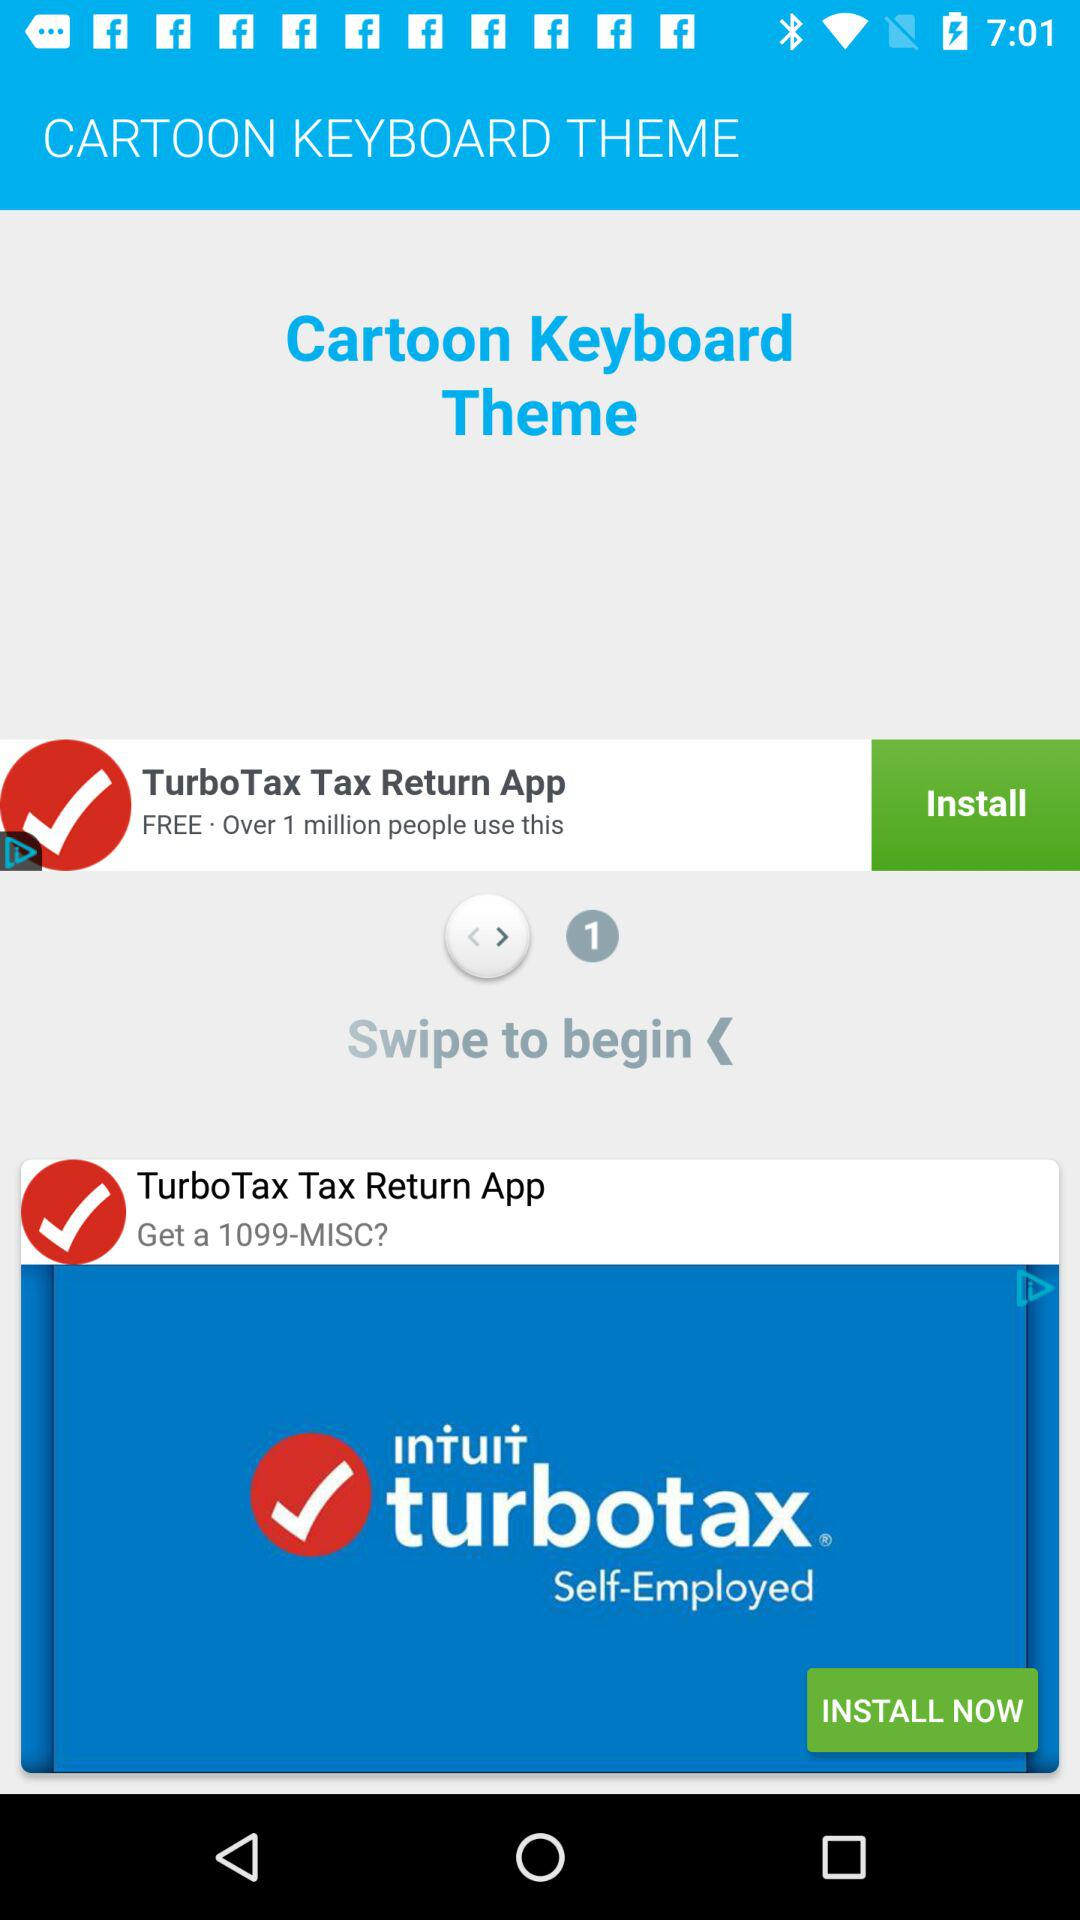What is the application name? The application name is "CARTOON KEYBOARD THEME". 